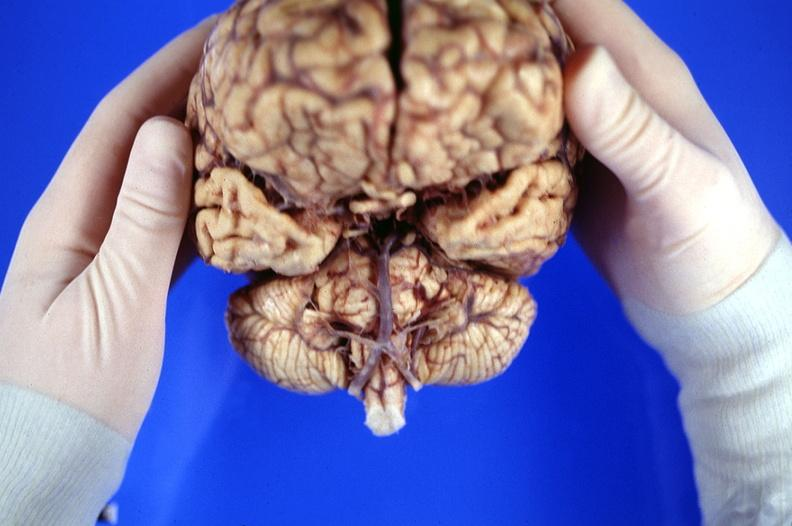does this image show brain, frontal lobe atrophy, pick 's disease?
Answer the question using a single word or phrase. Yes 